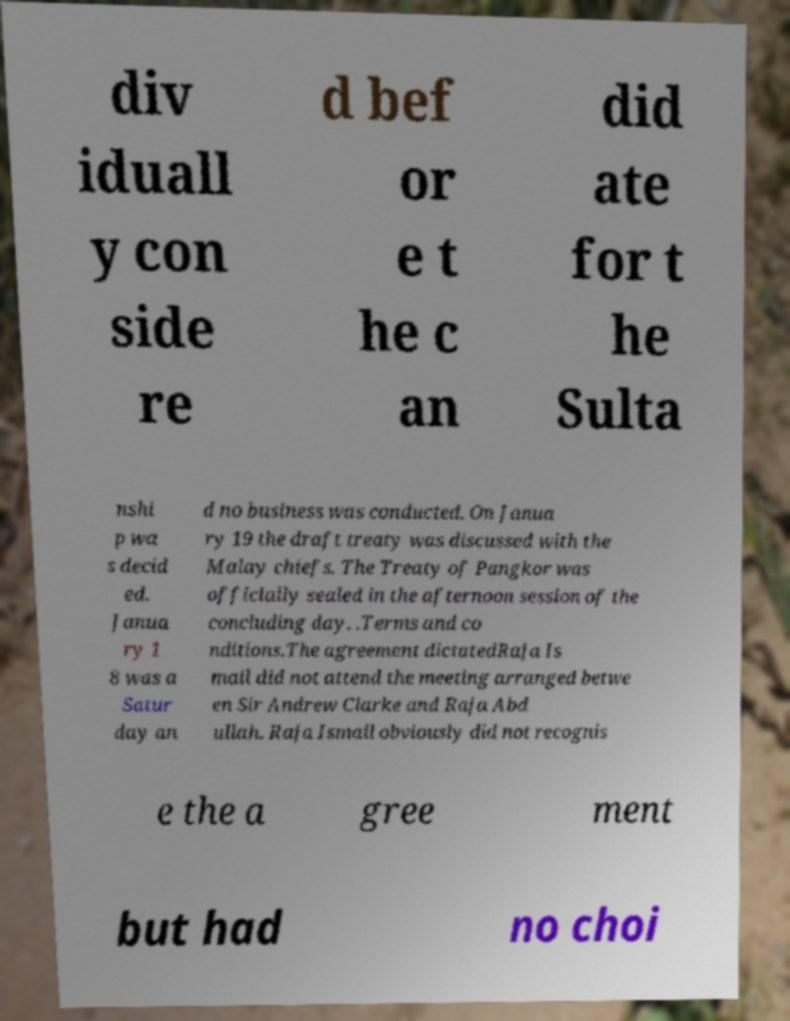For documentation purposes, I need the text within this image transcribed. Could you provide that? div iduall y con side re d bef or e t he c an did ate for t he Sulta nshi p wa s decid ed. Janua ry 1 8 was a Satur day an d no business was conducted. On Janua ry 19 the draft treaty was discussed with the Malay chiefs. The Treaty of Pangkor was officially sealed in the afternoon session of the concluding day. .Terms and co nditions.The agreement dictatedRaja Is mail did not attend the meeting arranged betwe en Sir Andrew Clarke and Raja Abd ullah. Raja Ismail obviously did not recognis e the a gree ment but had no choi 